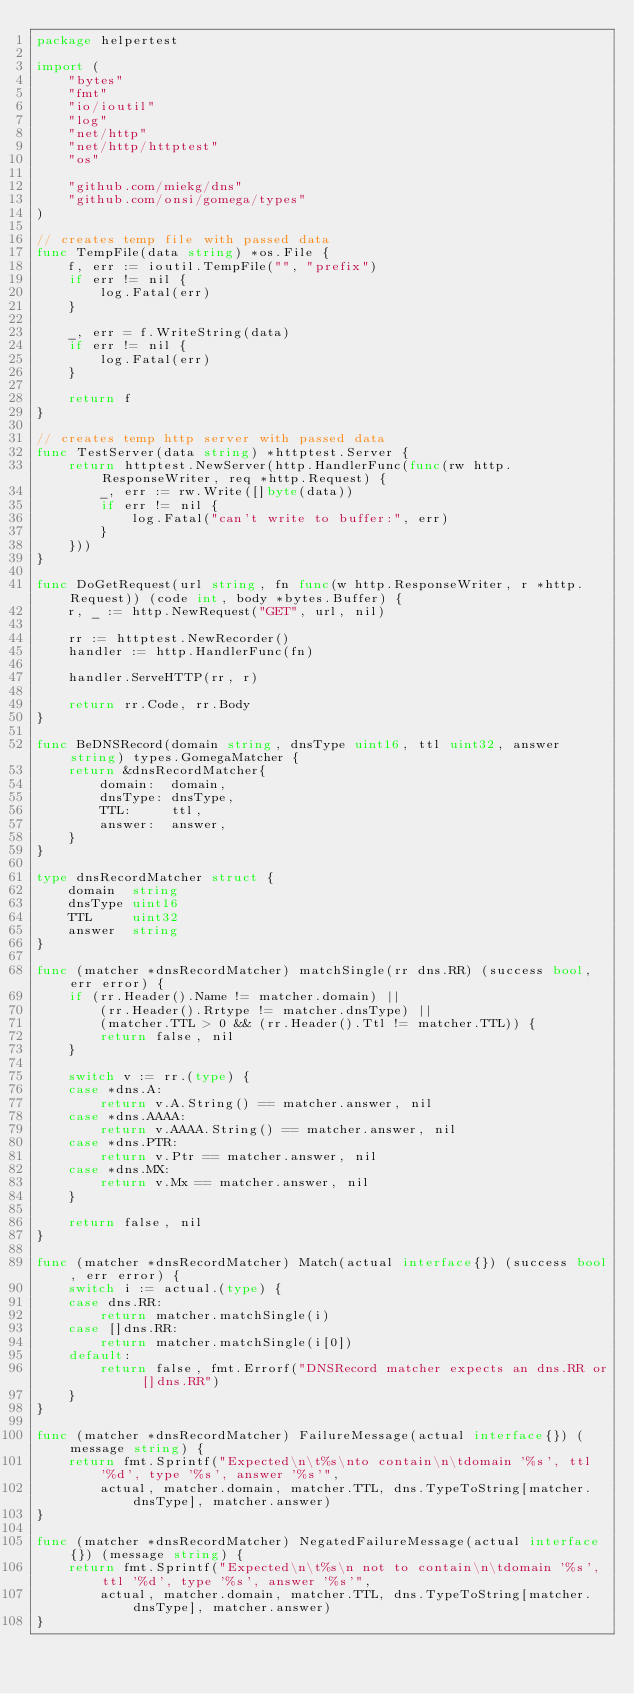Convert code to text. <code><loc_0><loc_0><loc_500><loc_500><_Go_>package helpertest

import (
	"bytes"
	"fmt"
	"io/ioutil"
	"log"
	"net/http"
	"net/http/httptest"
	"os"

	"github.com/miekg/dns"
	"github.com/onsi/gomega/types"
)

// creates temp file with passed data
func TempFile(data string) *os.File {
	f, err := ioutil.TempFile("", "prefix")
	if err != nil {
		log.Fatal(err)
	}

	_, err = f.WriteString(data)
	if err != nil {
		log.Fatal(err)
	}

	return f
}

// creates temp http server with passed data
func TestServer(data string) *httptest.Server {
	return httptest.NewServer(http.HandlerFunc(func(rw http.ResponseWriter, req *http.Request) {
		_, err := rw.Write([]byte(data))
		if err != nil {
			log.Fatal("can't write to buffer:", err)
		}
	}))
}

func DoGetRequest(url string, fn func(w http.ResponseWriter, r *http.Request)) (code int, body *bytes.Buffer) {
	r, _ := http.NewRequest("GET", url, nil)

	rr := httptest.NewRecorder()
	handler := http.HandlerFunc(fn)

	handler.ServeHTTP(rr, r)

	return rr.Code, rr.Body
}

func BeDNSRecord(domain string, dnsType uint16, ttl uint32, answer string) types.GomegaMatcher {
	return &dnsRecordMatcher{
		domain:  domain,
		dnsType: dnsType,
		TTL:     ttl,
		answer:  answer,
	}
}

type dnsRecordMatcher struct {
	domain  string
	dnsType uint16
	TTL     uint32
	answer  string
}

func (matcher *dnsRecordMatcher) matchSingle(rr dns.RR) (success bool, err error) {
	if (rr.Header().Name != matcher.domain) ||
		(rr.Header().Rrtype != matcher.dnsType) ||
		(matcher.TTL > 0 && (rr.Header().Ttl != matcher.TTL)) {
		return false, nil
	}

	switch v := rr.(type) {
	case *dns.A:
		return v.A.String() == matcher.answer, nil
	case *dns.AAAA:
		return v.AAAA.String() == matcher.answer, nil
	case *dns.PTR:
		return v.Ptr == matcher.answer, nil
	case *dns.MX:
		return v.Mx == matcher.answer, nil
	}

	return false, nil
}

func (matcher *dnsRecordMatcher) Match(actual interface{}) (success bool, err error) {
	switch i := actual.(type) {
	case dns.RR:
		return matcher.matchSingle(i)
	case []dns.RR:
		return matcher.matchSingle(i[0])
	default:
		return false, fmt.Errorf("DNSRecord matcher expects an dns.RR or []dns.RR")
	}
}

func (matcher *dnsRecordMatcher) FailureMessage(actual interface{}) (message string) {
	return fmt.Sprintf("Expected\n\t%s\nto contain\n\tdomain '%s', ttl '%d', type '%s', answer '%s'",
		actual, matcher.domain, matcher.TTL, dns.TypeToString[matcher.dnsType], matcher.answer)
}

func (matcher *dnsRecordMatcher) NegatedFailureMessage(actual interface{}) (message string) {
	return fmt.Sprintf("Expected\n\t%s\n not to contain\n\tdomain '%s', ttl '%d', type '%s', answer '%s'",
		actual, matcher.domain, matcher.TTL, dns.TypeToString[matcher.dnsType], matcher.answer)
}
</code> 